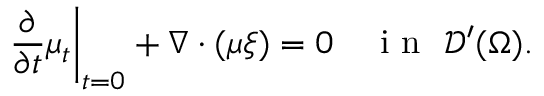<formula> <loc_0><loc_0><loc_500><loc_500>\frac { \partial } { \partial t } \mu _ { t } \right | _ { t = 0 } + \nabla \cdot ( \mu \xi ) = 0 \quad i n \, \mathcal { D } ^ { \prime } ( \Omega ) .</formula> 